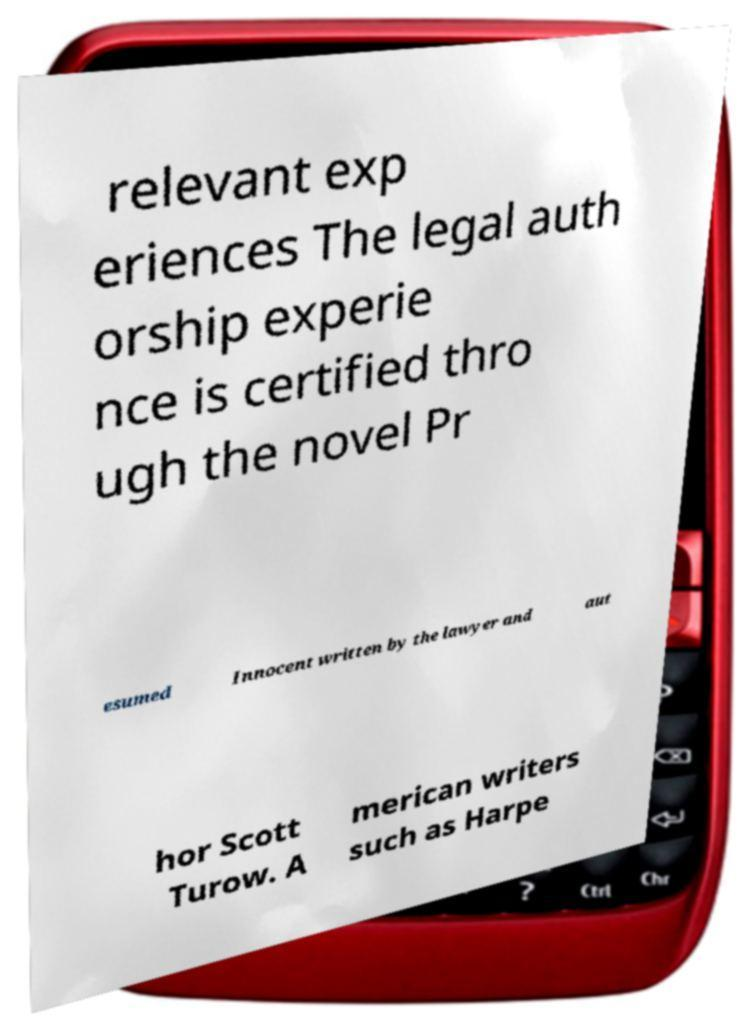Can you accurately transcribe the text from the provided image for me? relevant exp eriences The legal auth orship experie nce is certified thro ugh the novel Pr esumed Innocent written by the lawyer and aut hor Scott Turow. A merican writers such as Harpe 